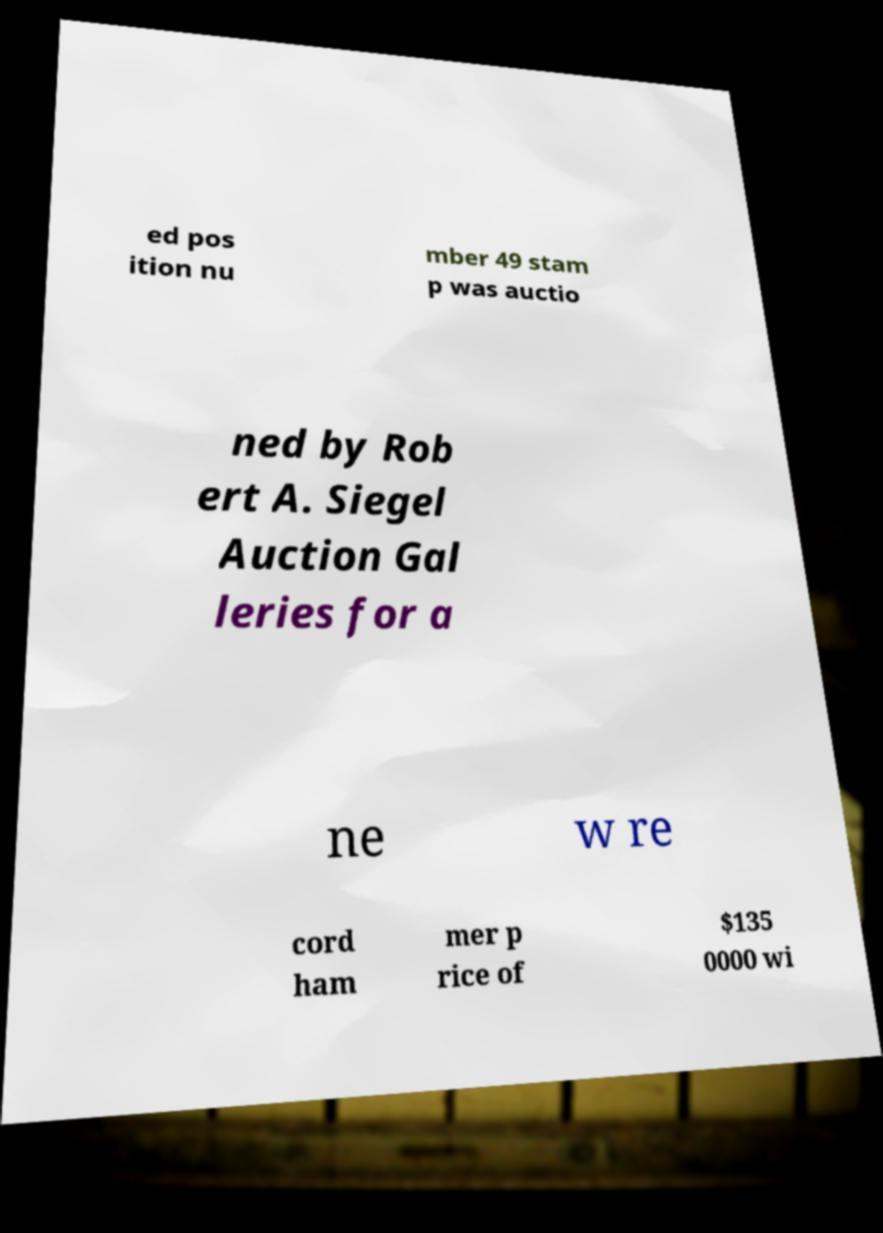Can you accurately transcribe the text from the provided image for me? ed pos ition nu mber 49 stam p was auctio ned by Rob ert A. Siegel Auction Gal leries for a ne w re cord ham mer p rice of $135 0000 wi 